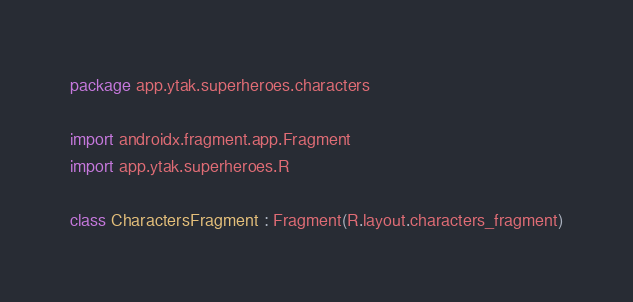Convert code to text. <code><loc_0><loc_0><loc_500><loc_500><_Kotlin_>package app.ytak.superheroes.characters

import androidx.fragment.app.Fragment
import app.ytak.superheroes.R

class CharactersFragment : Fragment(R.layout.characters_fragment)
</code> 